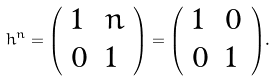Convert formula to latex. <formula><loc_0><loc_0><loc_500><loc_500>h ^ { n } = { \left ( \begin{array} { l l } { 1 } & { n } \\ { 0 } & { 1 } \end{array} \right ) } = { \left ( \begin{array} { l l } { 1 } & { 0 } \\ { 0 } & { 1 } \end{array} \right ) } .</formula> 